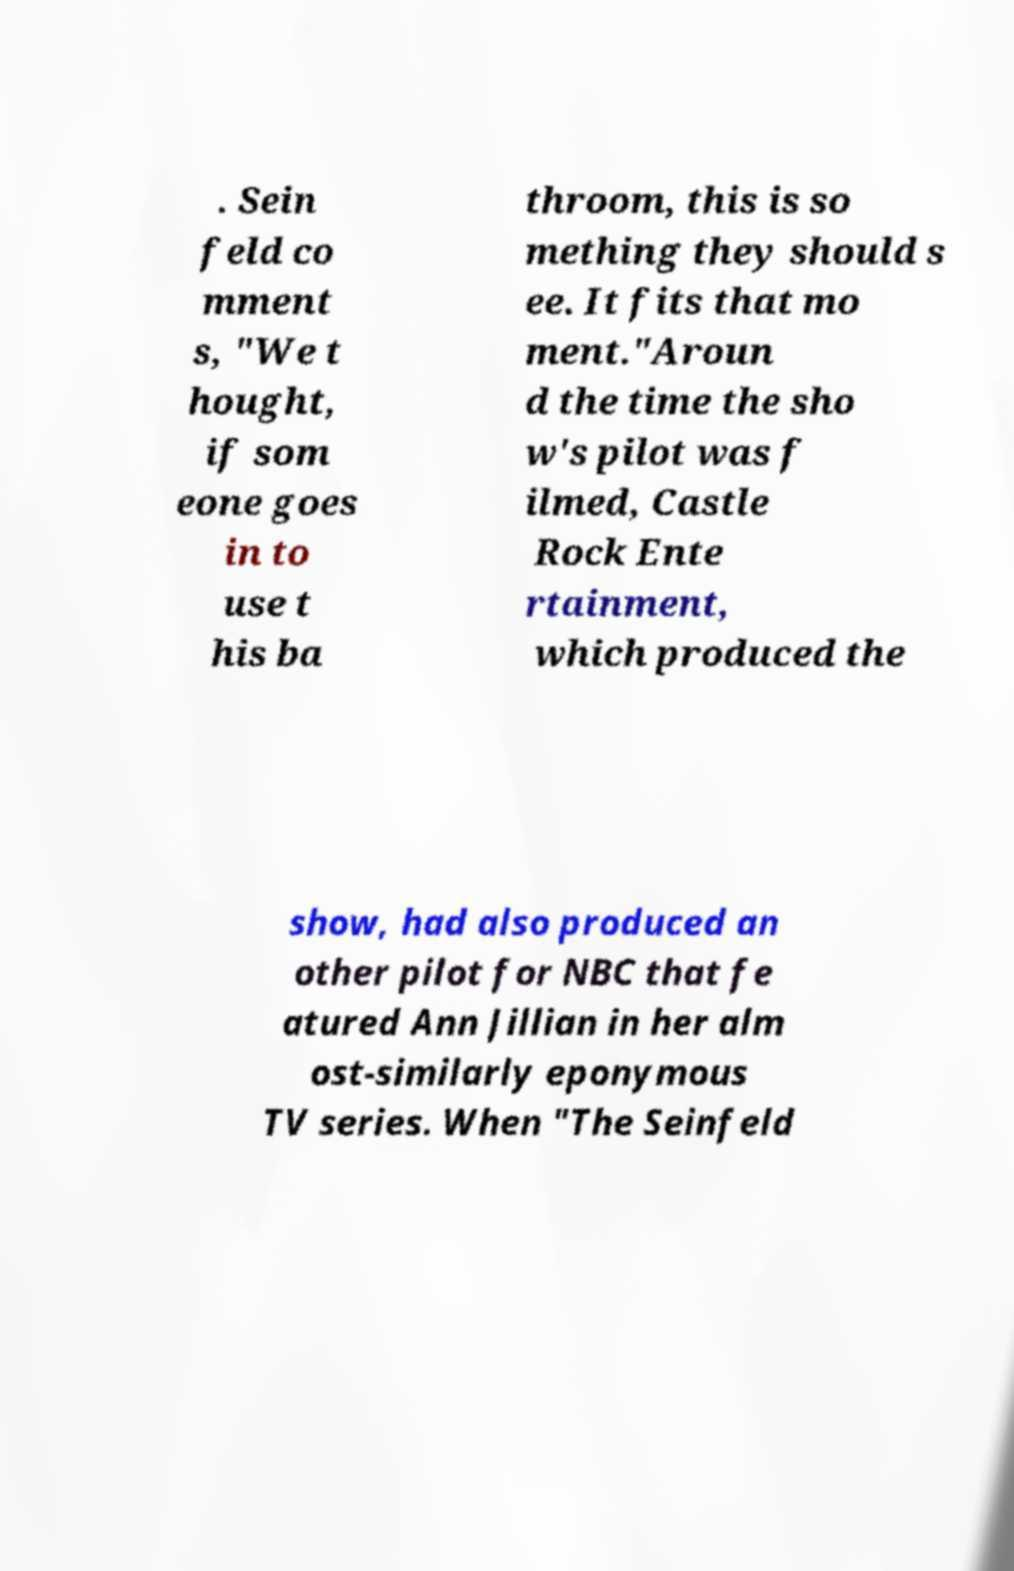What messages or text are displayed in this image? I need them in a readable, typed format. . Sein feld co mment s, "We t hought, if som eone goes in to use t his ba throom, this is so mething they should s ee. It fits that mo ment."Aroun d the time the sho w's pilot was f ilmed, Castle Rock Ente rtainment, which produced the show, had also produced an other pilot for NBC that fe atured Ann Jillian in her alm ost-similarly eponymous TV series. When "The Seinfeld 